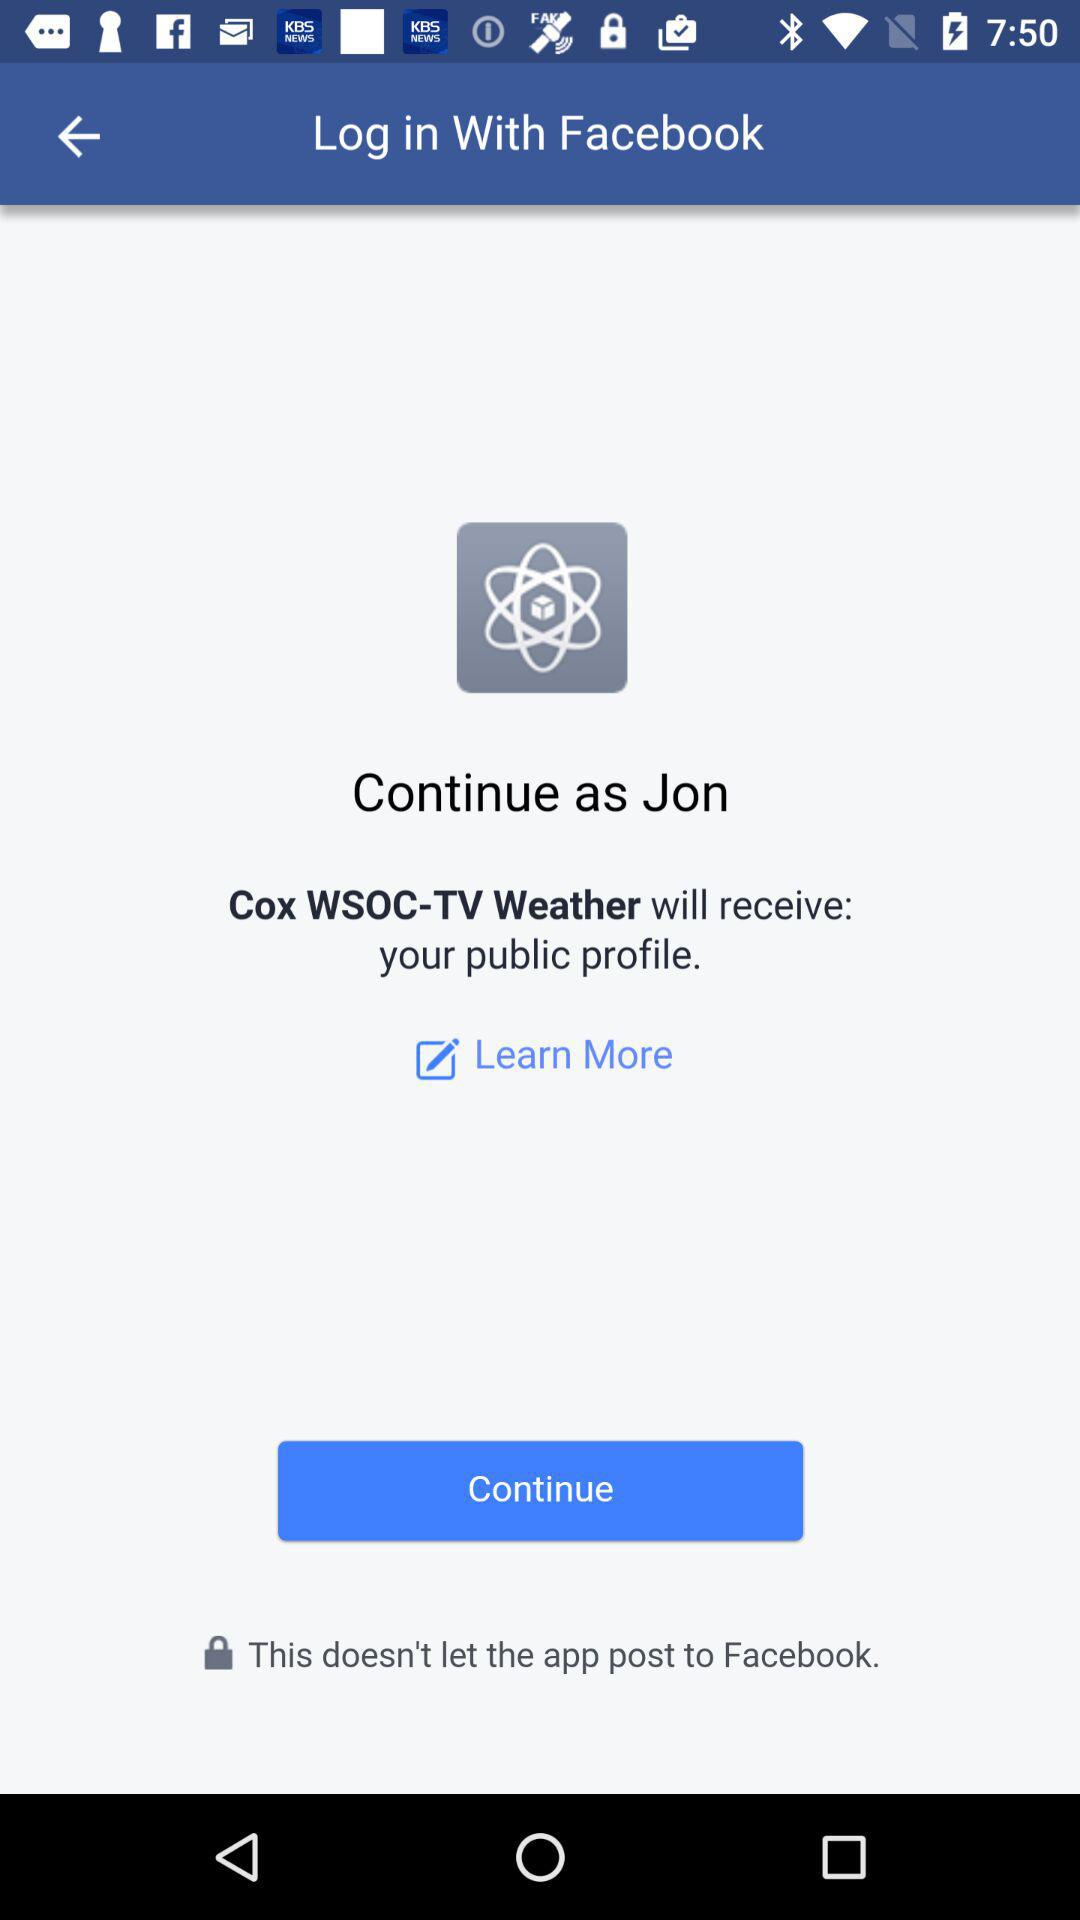What is the user name? The user name is Jon. 